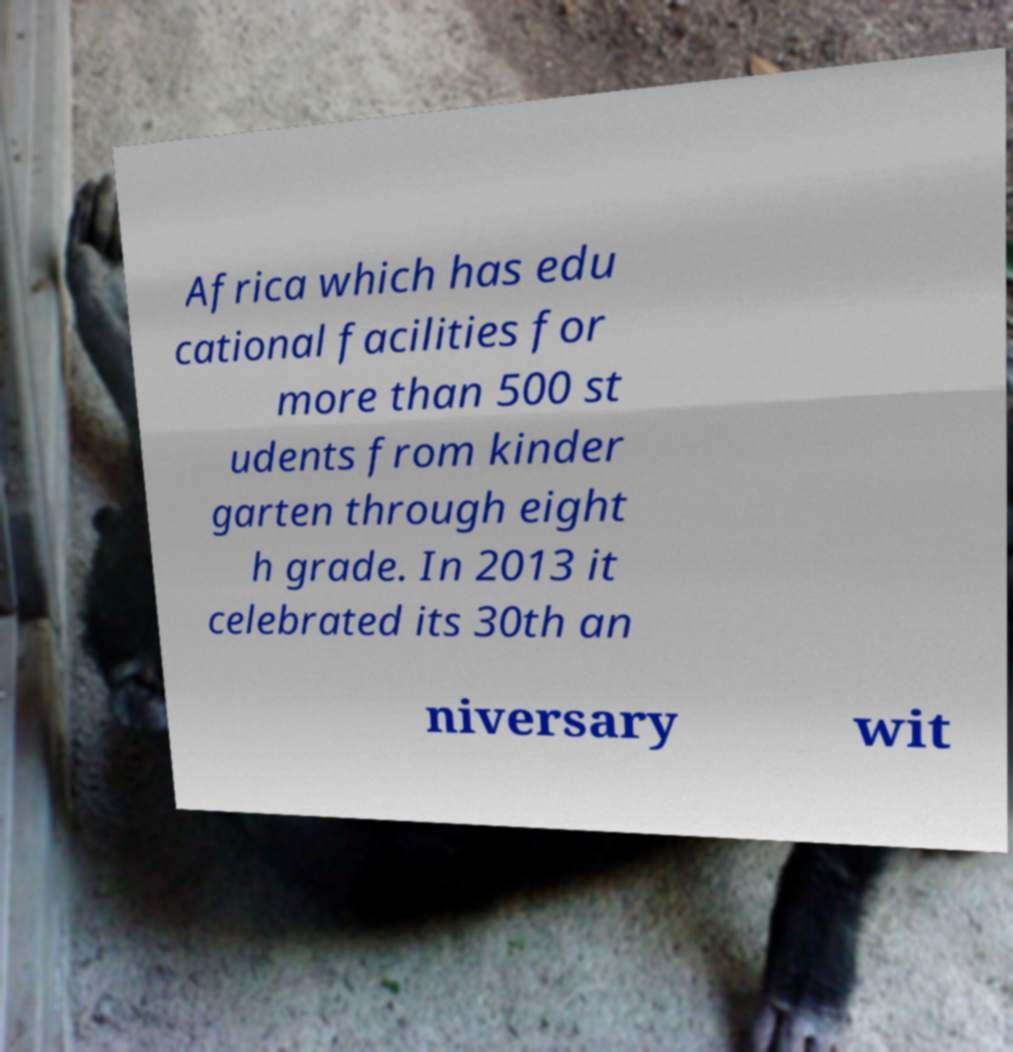For documentation purposes, I need the text within this image transcribed. Could you provide that? Africa which has edu cational facilities for more than 500 st udents from kinder garten through eight h grade. In 2013 it celebrated its 30th an niversary wit 